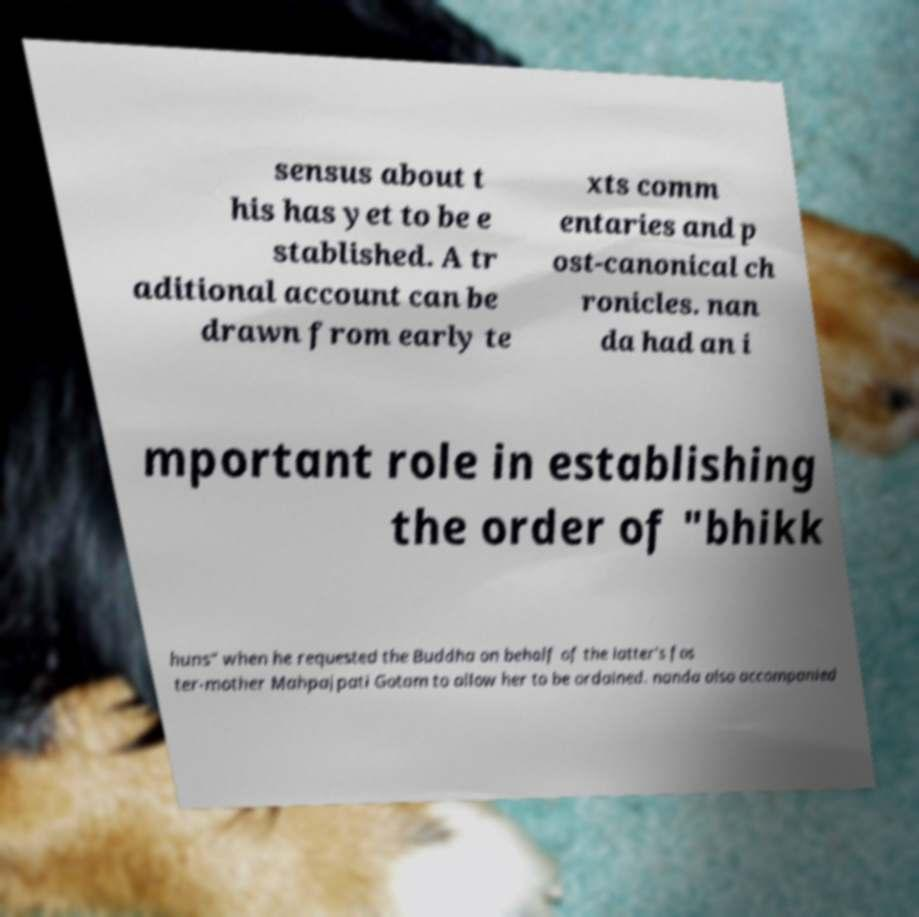For documentation purposes, I need the text within this image transcribed. Could you provide that? sensus about t his has yet to be e stablished. A tr aditional account can be drawn from early te xts comm entaries and p ost-canonical ch ronicles. nan da had an i mportant role in establishing the order of "bhikk huns" when he requested the Buddha on behalf of the latter's fos ter-mother Mahpajpati Gotam to allow her to be ordained. nanda also accompanied 